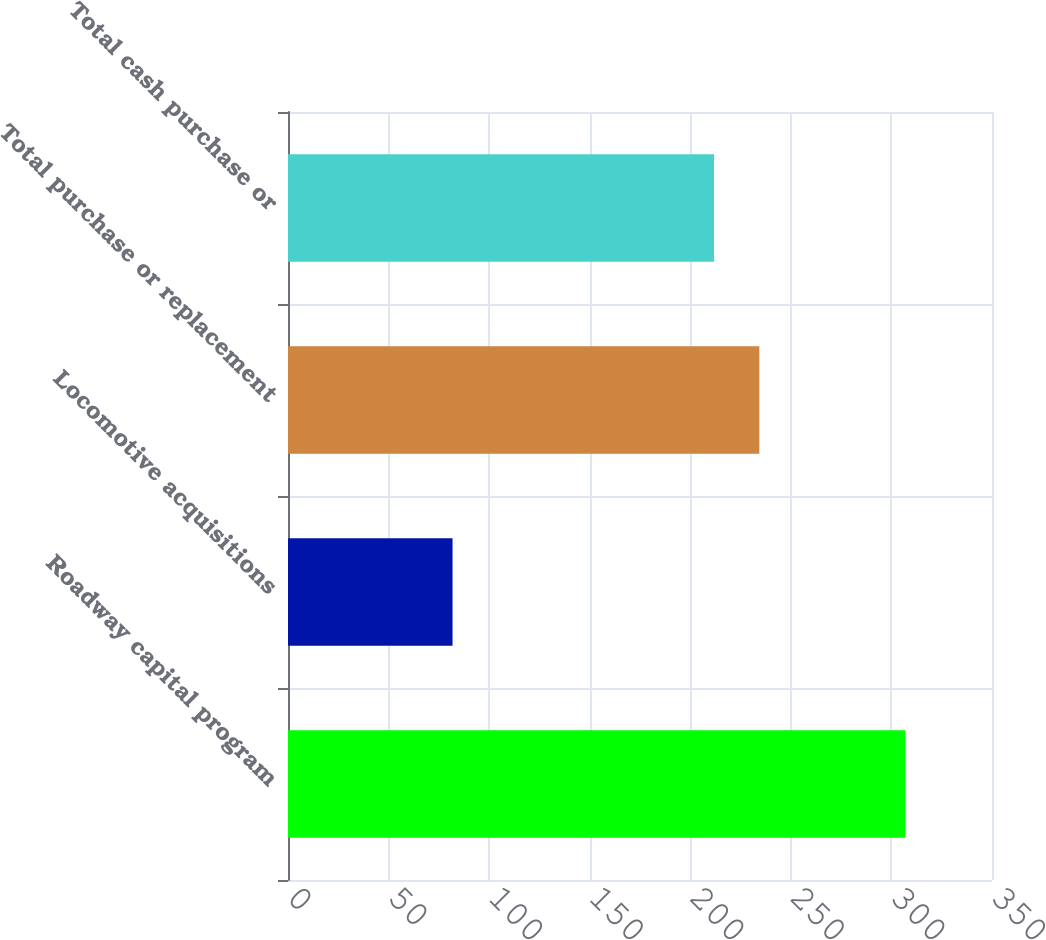Convert chart. <chart><loc_0><loc_0><loc_500><loc_500><bar_chart><fcel>Roadway capital program<fcel>Locomotive acquisitions<fcel>Total purchase or replacement<fcel>Total cash purchase or<nl><fcel>307<fcel>81.8<fcel>234.32<fcel>211.8<nl></chart> 